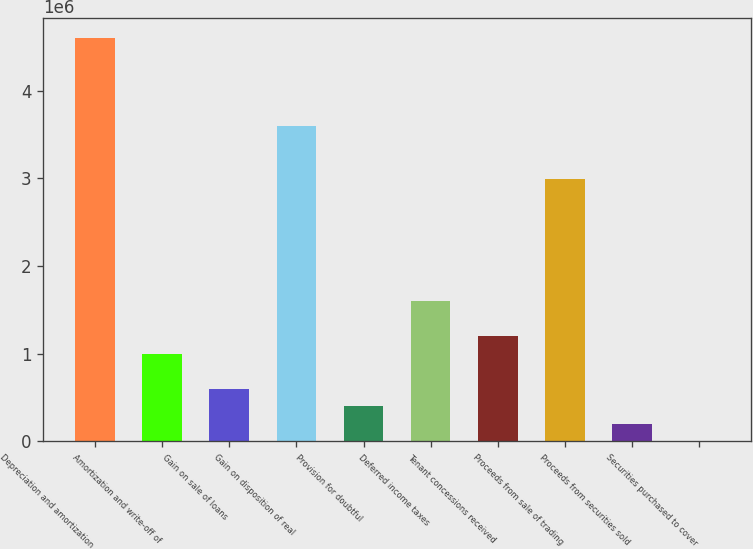Convert chart. <chart><loc_0><loc_0><loc_500><loc_500><bar_chart><fcel>Depreciation and amortization<fcel>Amortization and write-off of<fcel>Gain on sale of loans<fcel>Gain on disposition of real<fcel>Provision for doubtful<fcel>Deferred income taxes<fcel>Tenant concessions received<fcel>Proceeds from sale of trading<fcel>Proceeds from securities sold<fcel>Securities purchased to cover<nl><fcel>4.59808e+06<fcel>999938<fcel>600144<fcel>3.5986e+06<fcel>400247<fcel>1.59963e+06<fcel>1.19983e+06<fcel>2.99891e+06<fcel>200350<fcel>453<nl></chart> 